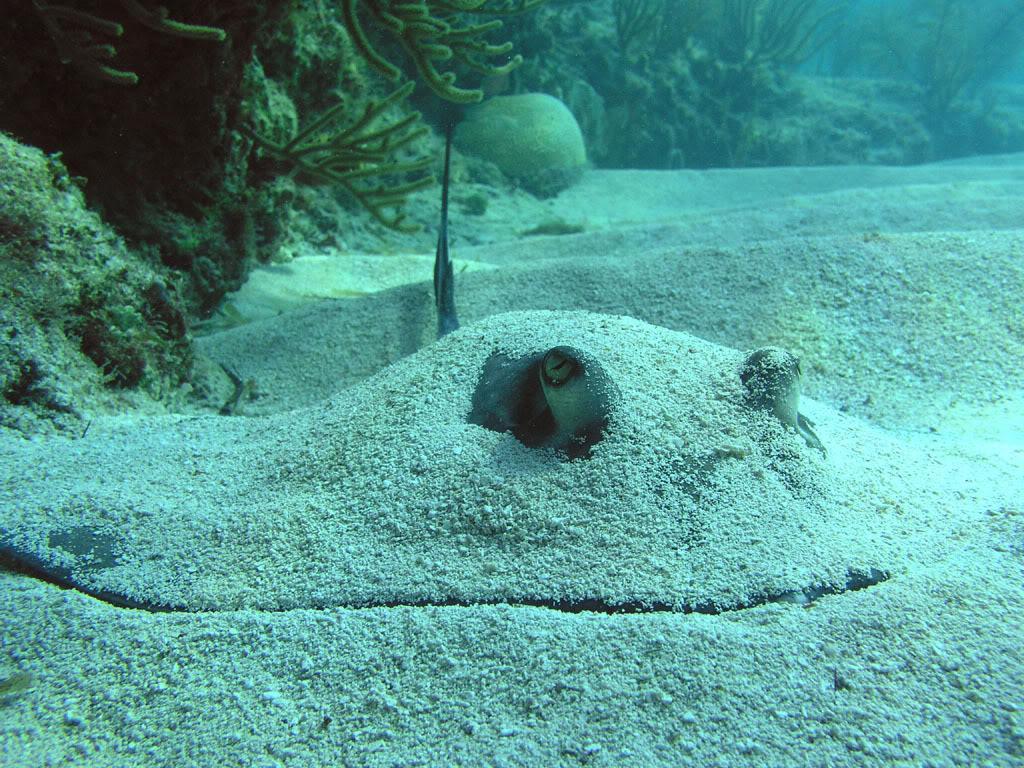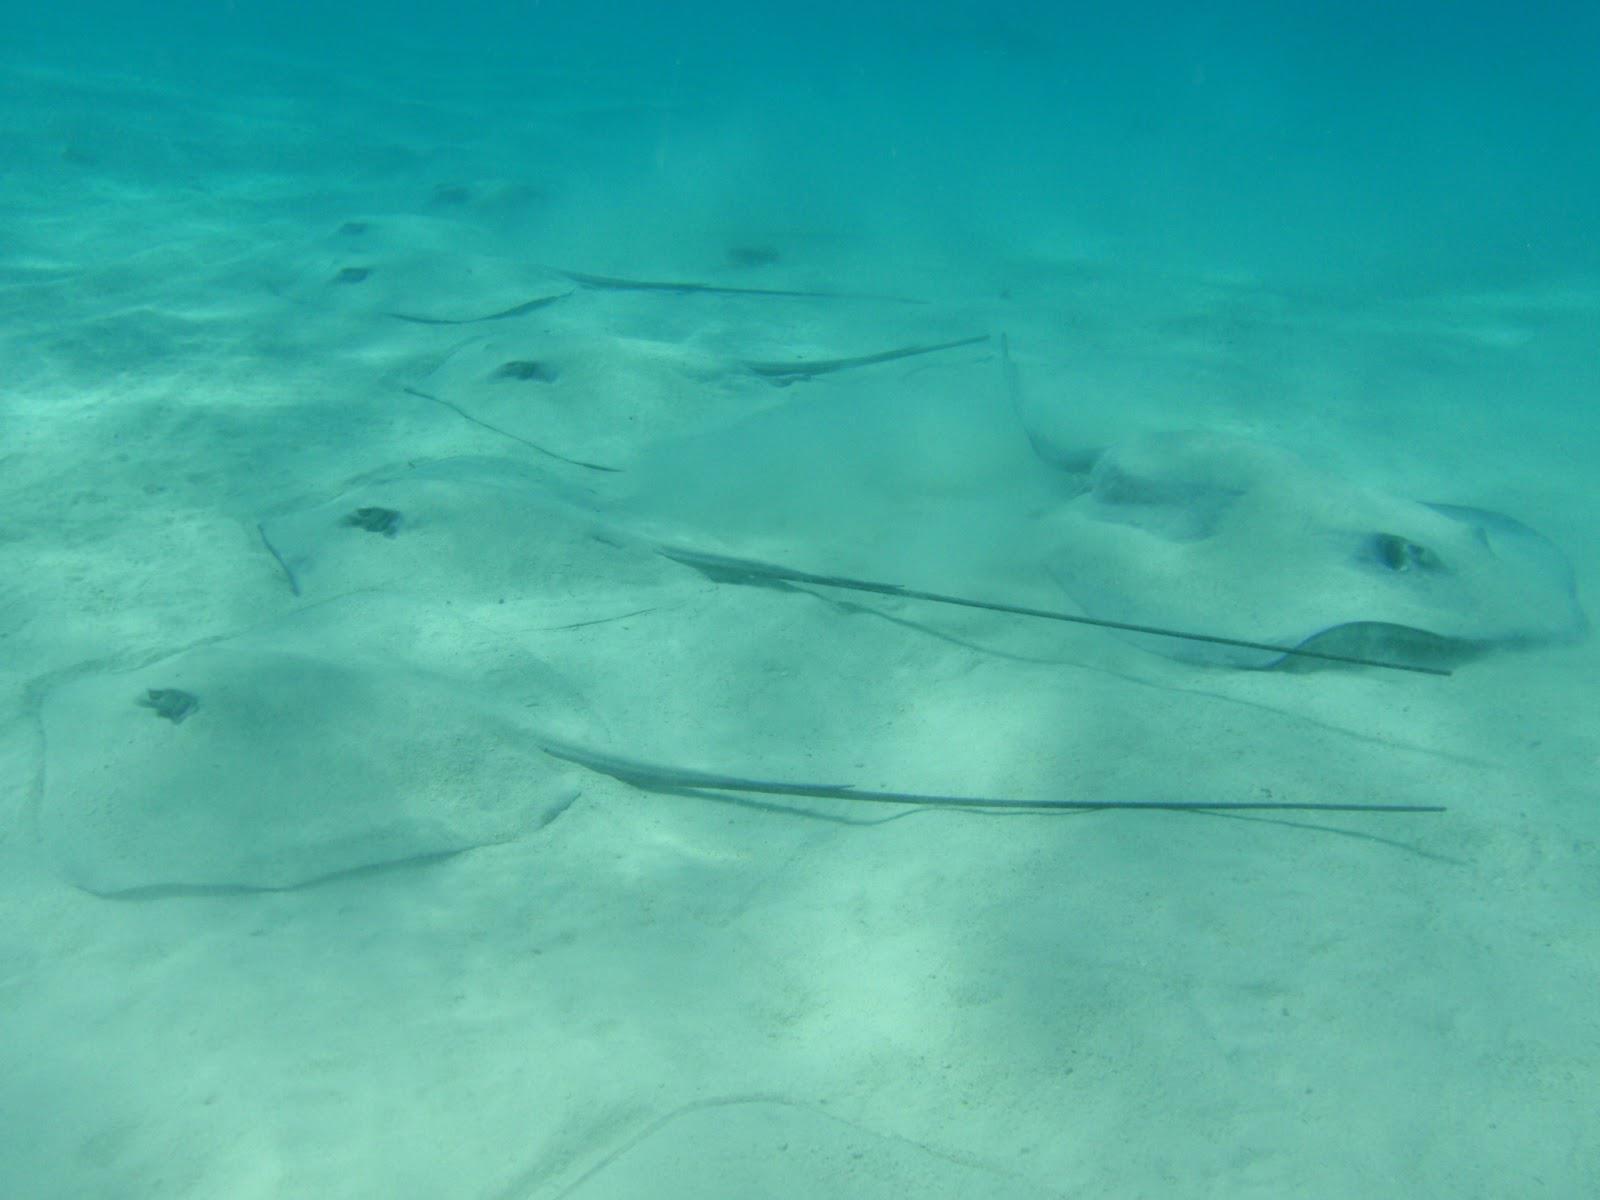The first image is the image on the left, the second image is the image on the right. Considering the images on both sides, is "The left image shows a Stingray swimming through the water." valid? Answer yes or no. No. The first image is the image on the left, the second image is the image on the right. Examine the images to the left and right. Is the description "All of the stingrays are laying on the ocean floor." accurate? Answer yes or no. Yes. 